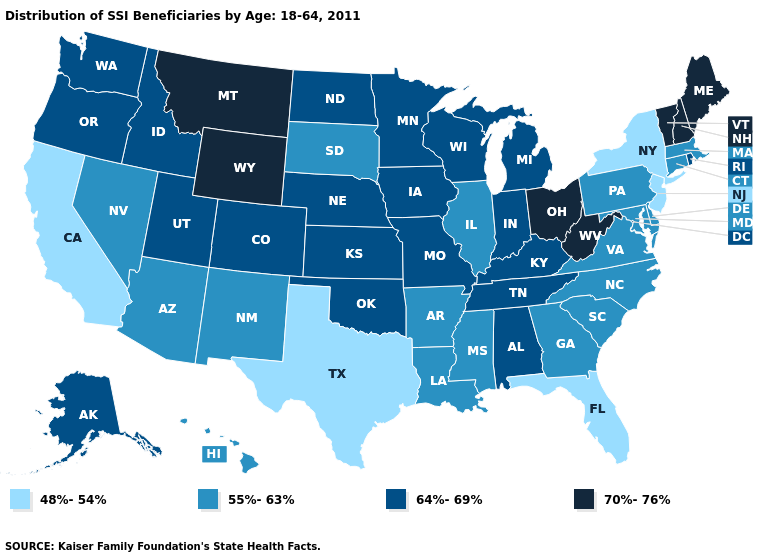What is the value of Georgia?
Keep it brief. 55%-63%. What is the value of New Mexico?
Be succinct. 55%-63%. Name the states that have a value in the range 64%-69%?
Give a very brief answer. Alabama, Alaska, Colorado, Idaho, Indiana, Iowa, Kansas, Kentucky, Michigan, Minnesota, Missouri, Nebraska, North Dakota, Oklahoma, Oregon, Rhode Island, Tennessee, Utah, Washington, Wisconsin. Name the states that have a value in the range 64%-69%?
Short answer required. Alabama, Alaska, Colorado, Idaho, Indiana, Iowa, Kansas, Kentucky, Michigan, Minnesota, Missouri, Nebraska, North Dakota, Oklahoma, Oregon, Rhode Island, Tennessee, Utah, Washington, Wisconsin. Which states have the highest value in the USA?
Keep it brief. Maine, Montana, New Hampshire, Ohio, Vermont, West Virginia, Wyoming. Name the states that have a value in the range 55%-63%?
Be succinct. Arizona, Arkansas, Connecticut, Delaware, Georgia, Hawaii, Illinois, Louisiana, Maryland, Massachusetts, Mississippi, Nevada, New Mexico, North Carolina, Pennsylvania, South Carolina, South Dakota, Virginia. What is the lowest value in the Northeast?
Concise answer only. 48%-54%. Is the legend a continuous bar?
Write a very short answer. No. Name the states that have a value in the range 55%-63%?
Quick response, please. Arizona, Arkansas, Connecticut, Delaware, Georgia, Hawaii, Illinois, Louisiana, Maryland, Massachusetts, Mississippi, Nevada, New Mexico, North Carolina, Pennsylvania, South Carolina, South Dakota, Virginia. What is the lowest value in the South?
Concise answer only. 48%-54%. Name the states that have a value in the range 64%-69%?
Write a very short answer. Alabama, Alaska, Colorado, Idaho, Indiana, Iowa, Kansas, Kentucky, Michigan, Minnesota, Missouri, Nebraska, North Dakota, Oklahoma, Oregon, Rhode Island, Tennessee, Utah, Washington, Wisconsin. What is the lowest value in states that border Rhode Island?
Short answer required. 55%-63%. Name the states that have a value in the range 70%-76%?
Quick response, please. Maine, Montana, New Hampshire, Ohio, Vermont, West Virginia, Wyoming. Among the states that border South Carolina , which have the lowest value?
Answer briefly. Georgia, North Carolina. Name the states that have a value in the range 55%-63%?
Be succinct. Arizona, Arkansas, Connecticut, Delaware, Georgia, Hawaii, Illinois, Louisiana, Maryland, Massachusetts, Mississippi, Nevada, New Mexico, North Carolina, Pennsylvania, South Carolina, South Dakota, Virginia. 